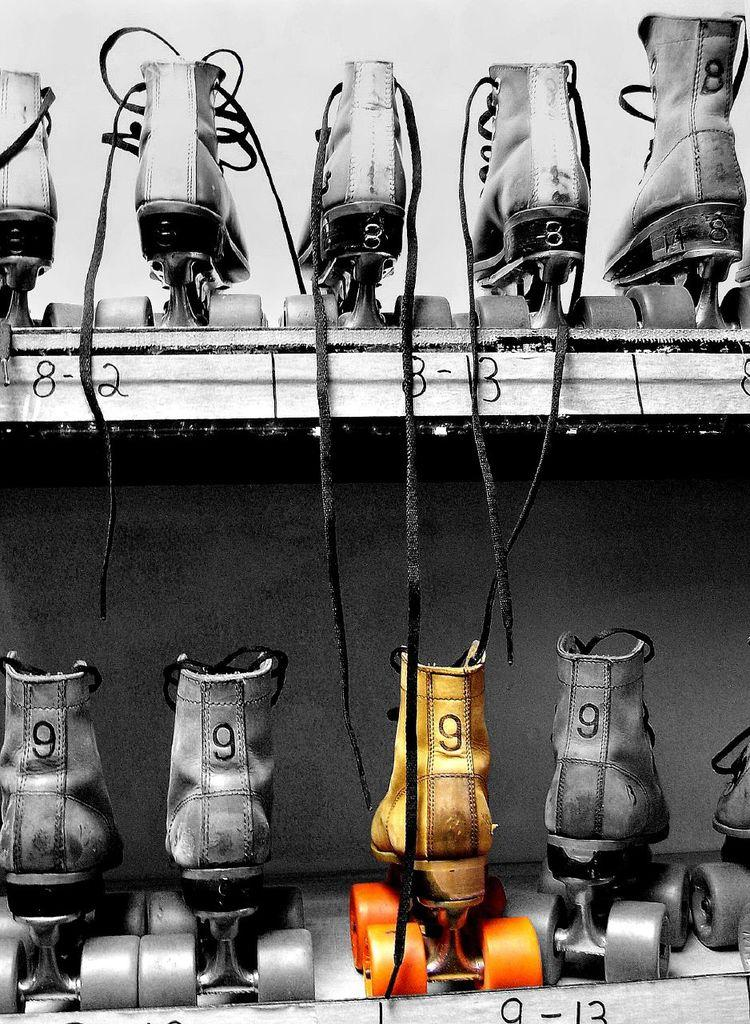What type of shoes can be seen in the image? There are skating shoes in the image. How are the skating shoes arranged in the image? The skating shoes are present in racks. What type of guide is holding a rifle in the image? There is no guide or rifle present in the image; it only mentions skating shoes in racks. 